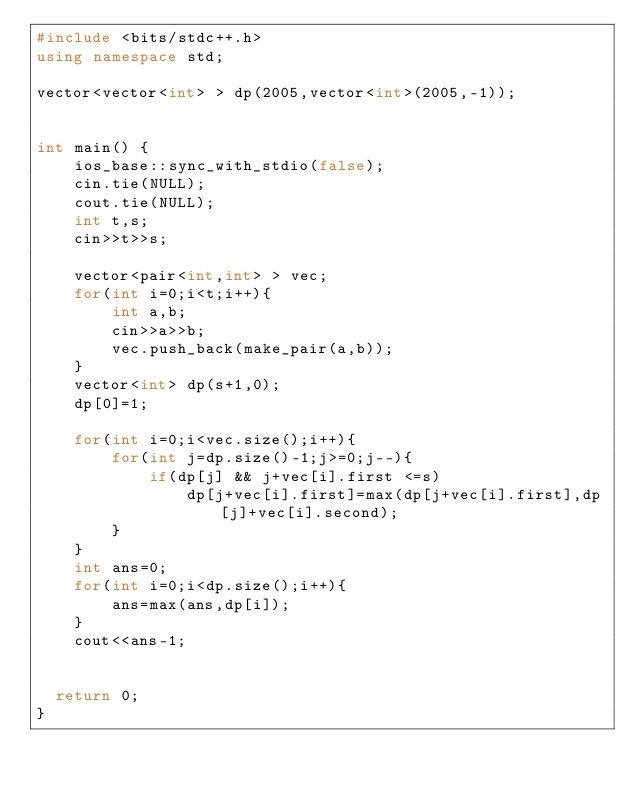Convert code to text. <code><loc_0><loc_0><loc_500><loc_500><_C++_>#include <bits/stdc++.h>
using namespace std;

vector<vector<int> > dp(2005,vector<int>(2005,-1));


int main() {
    ios_base::sync_with_stdio(false);
    cin.tie(NULL);
    cout.tie(NULL);
    int t,s;
    cin>>t>>s;
    
    vector<pair<int,int> > vec;
    for(int i=0;i<t;i++){
        int a,b;
        cin>>a>>b;
        vec.push_back(make_pair(a,b));
    }
    vector<int> dp(s+1,0);
    dp[0]=1;
    
    for(int i=0;i<vec.size();i++){
        for(int j=dp.size()-1;j>=0;j--){
            if(dp[j] && j+vec[i].first <=s)
                dp[j+vec[i].first]=max(dp[j+vec[i].first],dp[j]+vec[i].second);
        }
    }
    int ans=0;
    for(int i=0;i<dp.size();i++){
        ans=max(ans,dp[i]);
    }
    cout<<ans-1;
    
    
	return 0;
}</code> 